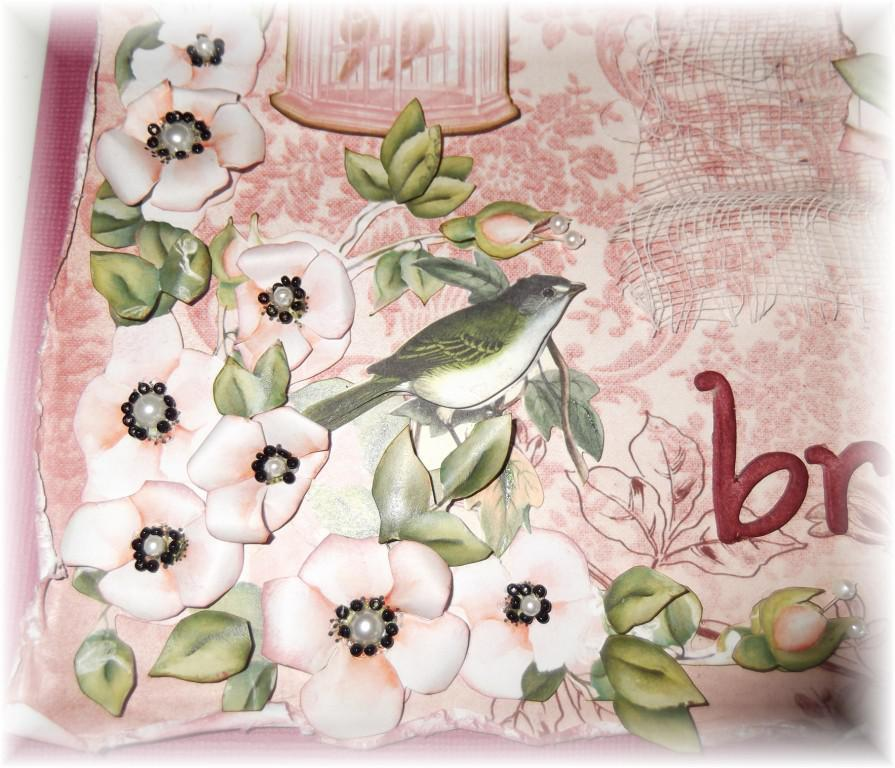What type of plants can be seen in the image? There are flowers and leaves in the image. What type of animal is present in the image? There is a bird in the image. What material is present in the image? There is mesh in the image. What is the object in the image? There is an object in the image, but its specific nature is not mentioned in the facts. What is written on a platform in the image? There is a text written on a platform in the image. What type of organization is depicted in the image? There is no organization depicted in the image; it features flowers, leaves, a bird, mesh, an object, and text on a platform. What type of insurance policy is being advertised in the image? There is no insurance policy being advertised in the image. What type of mist is covering the bird in the image? There is no mist present in the image; the bird is visible. 